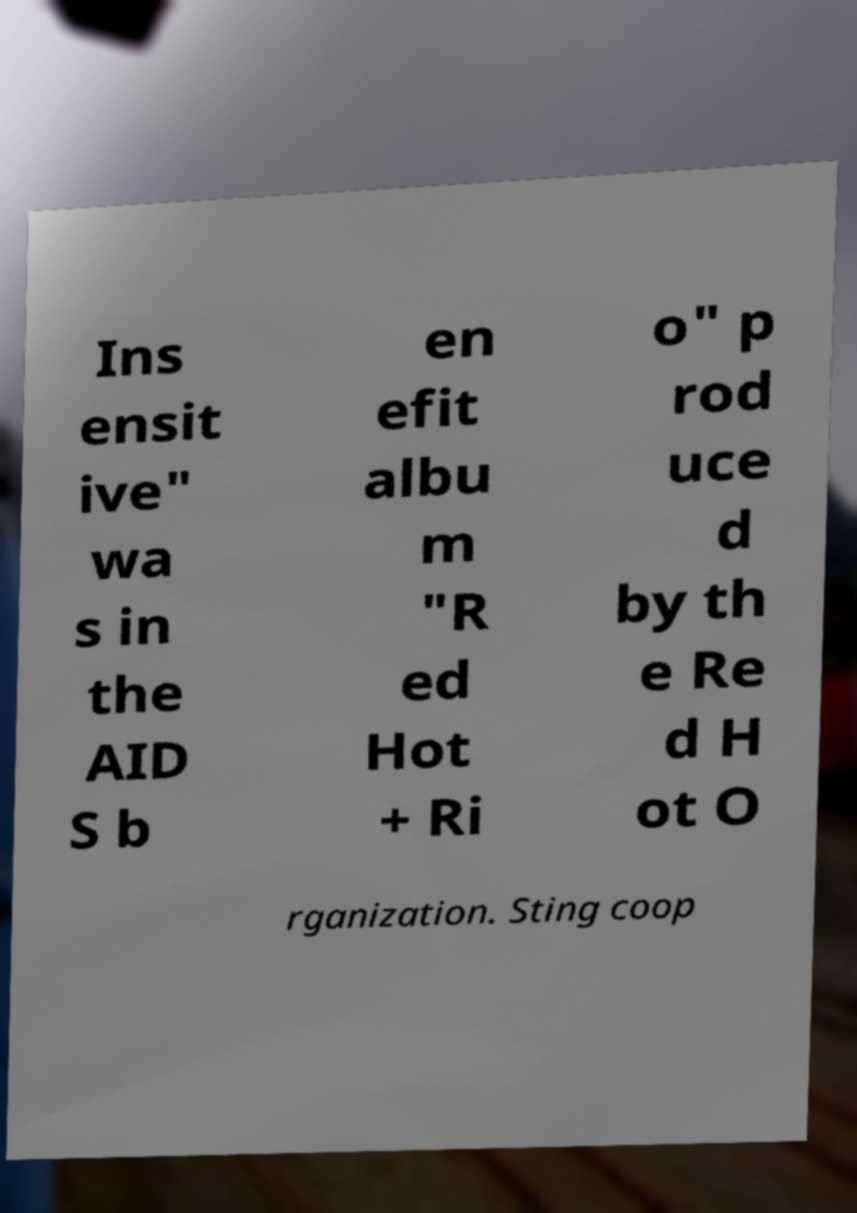For documentation purposes, I need the text within this image transcribed. Could you provide that? Ins ensit ive" wa s in the AID S b en efit albu m "R ed Hot + Ri o" p rod uce d by th e Re d H ot O rganization. Sting coop 